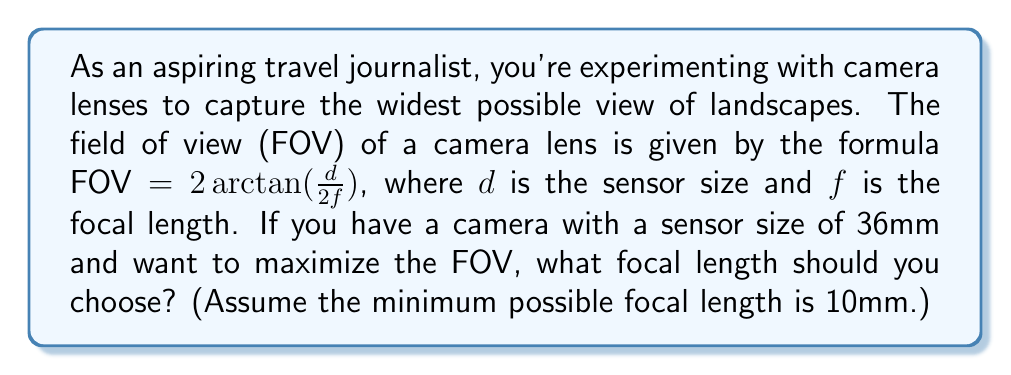Can you solve this math problem? To find the optimal focal length for the widest view, we need to maximize the FOV function:

1) The FOV function is: $FOV = 2 \arctan(\frac{d}{2f})$

2) We want to maximize this function. Since arctan is an increasing function, maximizing FOV is equivalent to maximizing $\frac{d}{2f}$

3) The sensor size $d$ is constant (36mm), so maximizing $\frac{d}{2f}$ is equivalent to minimizing $f$

4) The minimum possible focal length is given as 10mm

5) Therefore, to maximize the FOV, we should choose the smallest possible focal length, which is 10mm

6) We can calculate the maximum FOV:

   $FOV = 2 \arctan(\frac{36}{2(10)}) = 2 \arctan(1.8) \approx 2.034$ radians or about 116.6 degrees

[asy]
unitsize(1cm);
draw((-2,0)--(2,0),arrow=Arrow());
draw((0,-0.5)--(0,2),arrow=Arrow());
label("$f$",(2,-0.3));
label("FOV",(0,2.3));
path p = graph(function(real x) {2*atan(36/(2*x))}, 0.1, 2);
draw(p,red);
dot((0.5,2.034));
label("(10, 2.034)",(0.5,2.034),NE);
[/asy]
Answer: 10mm 